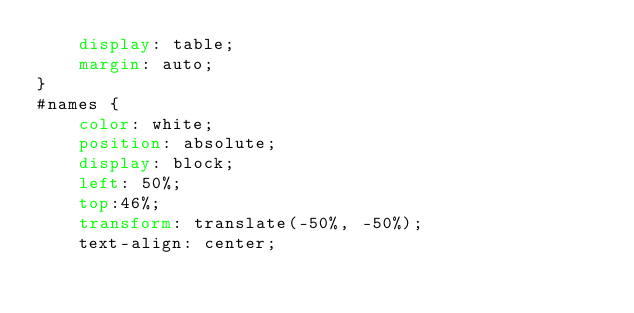<code> <loc_0><loc_0><loc_500><loc_500><_CSS_>    display: table; 
    margin: auto;
}
#names {
    color: white;
    position: absolute;
    display: block;
    left: 50%;
    top:46%;
    transform: translate(-50%, -50%);
    text-align: center;</code> 